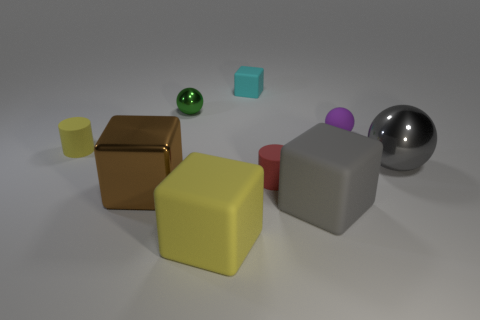What is the color of the other big block that is made of the same material as the big gray cube?
Give a very brief answer. Yellow. Are there more large cyan rubber objects than large yellow objects?
Your answer should be very brief. No. Do the cyan cube and the yellow cube have the same material?
Ensure brevity in your answer.  Yes. There is a big gray object that is made of the same material as the tiny yellow cylinder; what is its shape?
Keep it short and to the point. Cube. Is the number of large matte objects less than the number of big red cylinders?
Offer a very short reply. No. What material is the sphere that is left of the big gray metallic ball and right of the big gray rubber object?
Ensure brevity in your answer.  Rubber. There is a gray thing behind the gray thing that is left of the small sphere that is right of the small red rubber thing; what size is it?
Offer a terse response. Large. Does the large yellow object have the same shape as the big matte thing on the right side of the tiny cyan matte block?
Ensure brevity in your answer.  Yes. How many tiny objects are in front of the tiny green object and behind the tiny yellow cylinder?
Your answer should be compact. 1. What number of red objects are big rubber blocks or small matte cylinders?
Give a very brief answer. 1. 